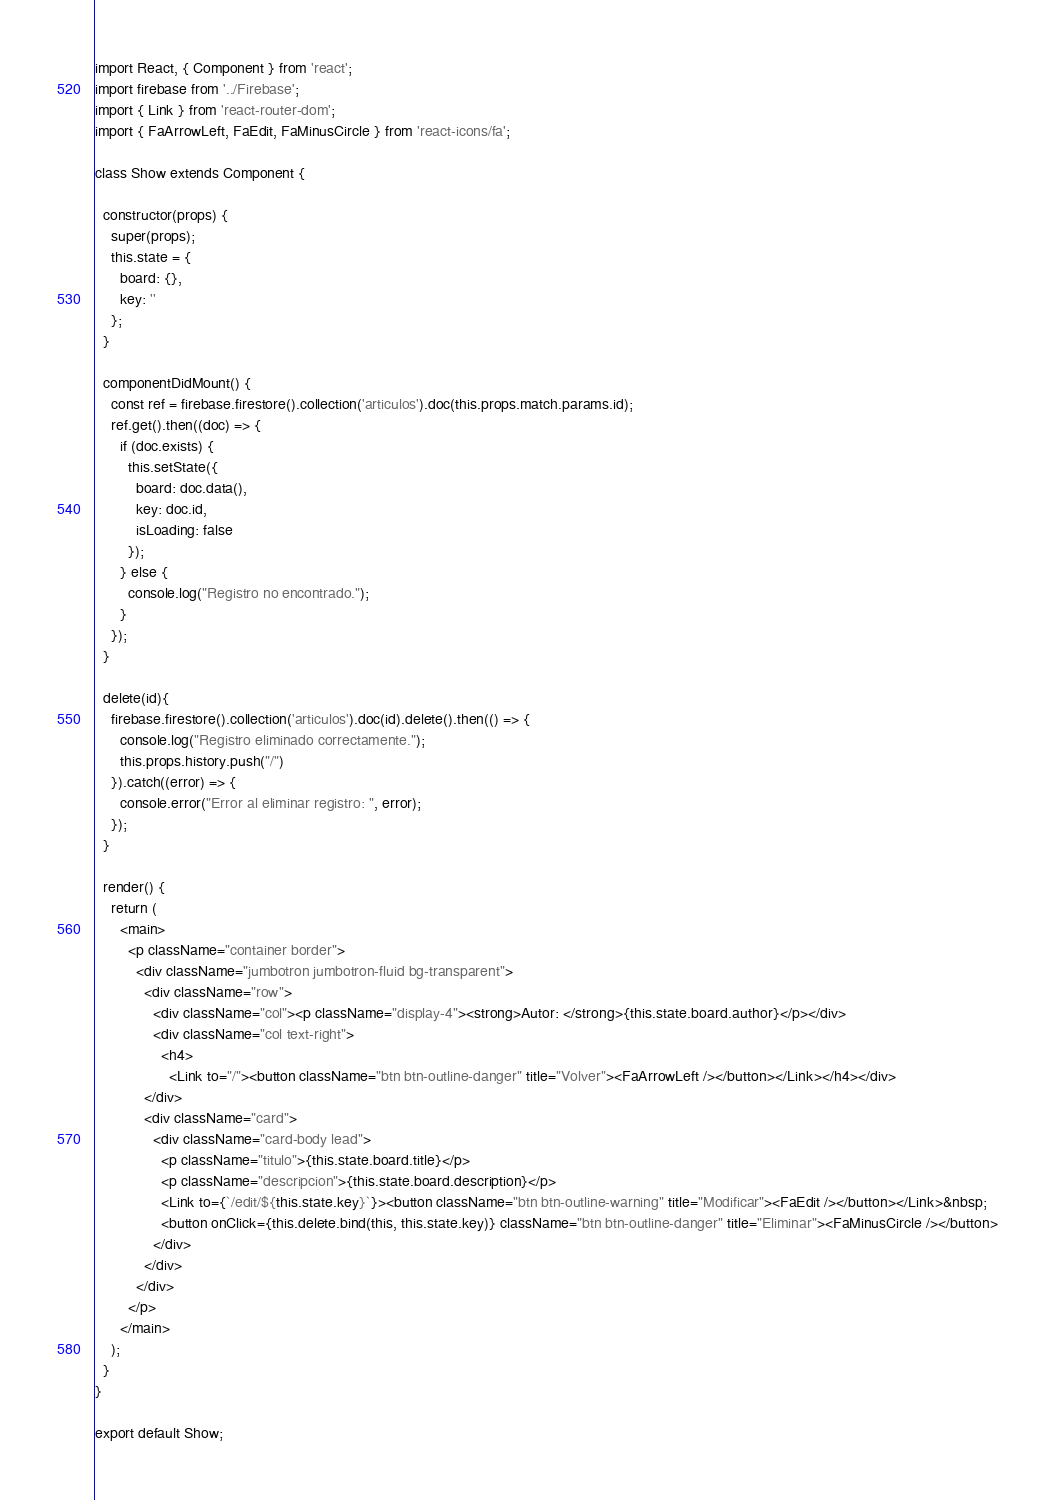<code> <loc_0><loc_0><loc_500><loc_500><_JavaScript_>import React, { Component } from 'react';
import firebase from '../Firebase';
import { Link } from 'react-router-dom';
import { FaArrowLeft, FaEdit, FaMinusCircle } from 'react-icons/fa';

class Show extends Component {

  constructor(props) {
    super(props);
    this.state = {
      board: {},
      key: ''
    };
  }

  componentDidMount() {
    const ref = firebase.firestore().collection('articulos').doc(this.props.match.params.id);
    ref.get().then((doc) => {
      if (doc.exists) {
        this.setState({
          board: doc.data(),
          key: doc.id,
          isLoading: false
        });
      } else {
        console.log("Registro no encontrado.");
      }
    });
  }

  delete(id){
    firebase.firestore().collection('articulos').doc(id).delete().then(() => {
      console.log("Registro eliminado correctamente.");
      this.props.history.push("/")
    }).catch((error) => {
      console.error("Error al eliminar registro: ", error);
    });
  }

  render() {
    return (
      <main>
        <p className="container border">
          <div className="jumbotron jumbotron-fluid bg-transparent">
            <div className="row">
              <div className="col"><p className="display-4"><strong>Autor: </strong>{this.state.board.author}</p></div>
              <div className="col text-right">
                <h4>
                  <Link to="/"><button className="btn btn-outline-danger" title="Volver"><FaArrowLeft /></button></Link></h4></div>
            </div>
            <div className="card">
              <div className="card-body lead">
                <p className="titulo">{this.state.board.title}</p>
                <p className="descripcion">{this.state.board.description}</p>
                <Link to={`/edit/${this.state.key}`}><button className="btn btn-outline-warning" title="Modificar"><FaEdit /></button></Link>&nbsp;
                <button onClick={this.delete.bind(this, this.state.key)} className="btn btn-outline-danger" title="Eliminar"><FaMinusCircle /></button>
              </div>
            </div>              
          </div>        
        </p>
      </main>
    );
  }
}

export default Show;
</code> 